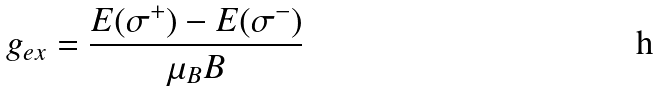Convert formula to latex. <formula><loc_0><loc_0><loc_500><loc_500>g _ { e x } = \frac { E ( \sigma ^ { + } ) - E ( \sigma ^ { - } ) } { \mu _ { B } B }</formula> 